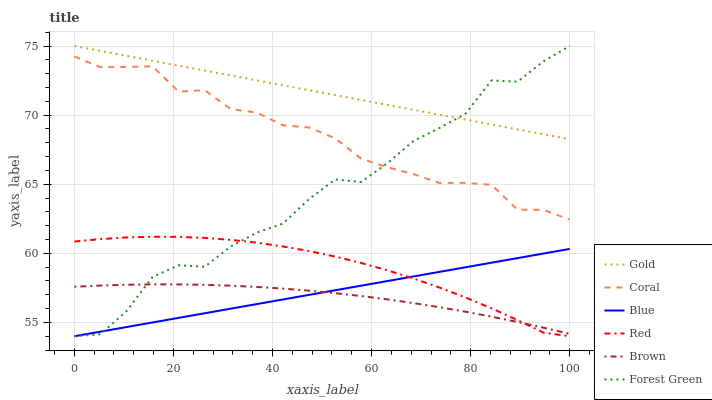Does Brown have the minimum area under the curve?
Answer yes or no. Yes. Does Gold have the maximum area under the curve?
Answer yes or no. Yes. Does Gold have the minimum area under the curve?
Answer yes or no. No. Does Brown have the maximum area under the curve?
Answer yes or no. No. Is Blue the smoothest?
Answer yes or no. Yes. Is Forest Green the roughest?
Answer yes or no. Yes. Is Brown the smoothest?
Answer yes or no. No. Is Brown the roughest?
Answer yes or no. No. Does Blue have the lowest value?
Answer yes or no. Yes. Does Brown have the lowest value?
Answer yes or no. No. Does Forest Green have the highest value?
Answer yes or no. Yes. Does Brown have the highest value?
Answer yes or no. No. Is Blue less than Gold?
Answer yes or no. Yes. Is Coral greater than Brown?
Answer yes or no. Yes. Does Coral intersect Forest Green?
Answer yes or no. Yes. Is Coral less than Forest Green?
Answer yes or no. No. Is Coral greater than Forest Green?
Answer yes or no. No. Does Blue intersect Gold?
Answer yes or no. No. 